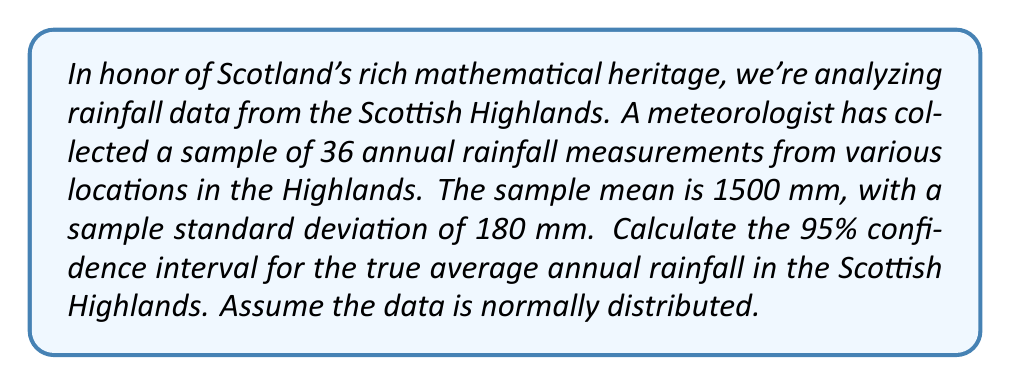Could you help me with this problem? Let's approach this step-by-step:

1) We're given:
   - Sample size: $n = 36$
   - Sample mean: $\bar{x} = 1500$ mm
   - Sample standard deviation: $s = 180$ mm
   - Confidence level: 95%

2) For a 95% confidence interval, we use a z-score of 1.96 (assuming a large sample size).

3) The formula for the confidence interval is:

   $$\bar{x} \pm z \cdot \frac{s}{\sqrt{n}}$$

4) Calculate the standard error:
   $$\frac{s}{\sqrt{n}} = \frac{180}{\sqrt{36}} = \frac{180}{6} = 30$$

5) Calculate the margin of error:
   $$1.96 \cdot 30 = 58.8$$

6) Now, we can construct the confidence interval:
   Lower bound: $1500 - 58.8 = 1441.2$ mm
   Upper bound: $1500 + 58.8 = 1558.8$ mm

Therefore, we are 95% confident that the true average annual rainfall in the Scottish Highlands falls between 1441.2 mm and 1558.8 mm.
Answer: (1441.2 mm, 1558.8 mm) 